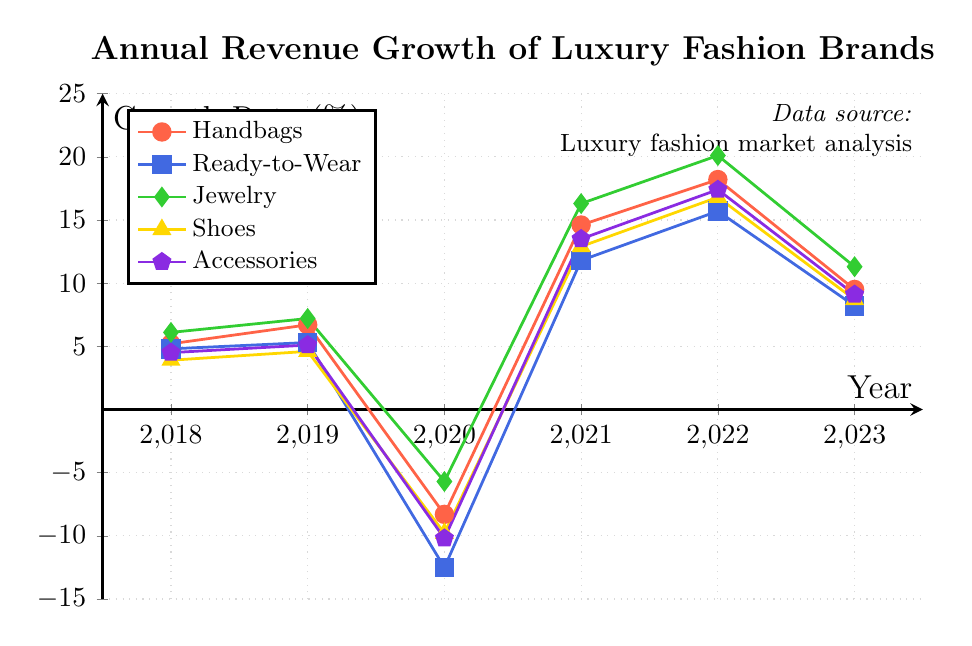What is the growth rate of Jewelry in 2022? To find the growth rate of Jewelry in 2022, look at the value corresponding to Jewelry for the year 2022 on the chart.
Answer: 20.1% How did the revenue growth rate for Ready-to-Wear change from 2020 to 2021? Look at the values for Ready-to-Wear in 2020 and 2021 and subtract the 2020 value from the 2021 value. The growth rate in 2020 was -12.5%, and in 2021 it was 11.8%. So, the change is 11.8 - (-12.5) = 24.3%.
Answer: 24.3% Which category had the highest revenue growth rate in 2019? Compare the growth rates of all categories for the year 2019. The values are 6.7% for Handbags, 5.3% for Ready-to-Wear, 7.2% for Jewelry, 4.6% for Shoes, and 5.1% for Accessories. Jewelry has the highest growth rate.
Answer: Jewelry Between which two consecutive years did Handbags experience the greatest increase in growth rate? Check the growth rates of Handbags for each pair of consecutive years: 
From 2018 to 2019: 6.7 - 5.2 = 1.5 
From 2019 to 2020: -8.3 - 6.7 = -15 (decrease)
From 2020 to 2021: 14.6 - (-8.3) = 22.9 
From 2021 to 2022: 18.2 - 14.6 = 3.6 
From 2022 to 2023: 9.5 - 18.2 = -8.7 (decrease)
The greatest increase is from 2020 to 2021.
Answer: 2020 to 2021 Which category shows the highest variability in growth rate over the years? To find the highest variability, look at the range (difference between the maximum and minimum values) for each category:
Handbags: 18.2 - (-8.3) = 26.5
Ready-to-Wear: 15.7 - (-12.5) = 28.2
Jewelry: 20.1 - (-5.7) = 25.8
Shoes: 16.8 - (-9.8) = 26.6
Accessories: 17.4 - (-10.2) = 27.6
Ready-to-Wear shows the highest variability.
Answer: Ready-to-Wear What is the average growth rate for Accessories from 2018 to 2023? The growth rates for Accessories are 4.5, 5.1, -10.2, 13.5, 17.4, and 9.1. Sum these values and divide by the number of years: (4.5 + 5.1 - 10.2 + 13.5 + 17.4 + 9.1) / 6 = 6.23.
Answer: 6.23 Among all the categories, which one had the lowest growth rate in 2023? Compare the growth rates for all categories in 2023: Handbags (9.5), Ready-to-Wear (8.2), Jewelry (11.3), Shoes (8.7), and Accessories (9.1). Ready-to-Wear had the lowest growth rate.
Answer: Ready-to-Wear How does the growth rate of Shoes in 2020 compare to the growth rate of Accessories in the same year? Look at the values for Shoes and Accessories in 2020: Shoes (-9.8%) and Accessories (-10.2%). Shoes had a better (less negative) growth rate than Accessories in 2020.
Answer: Shoes had a better growth rate If you average the growth rate of Handbags and Shoes in 2022, what do you get? Add the growth rates of Handbags (18.2) and Shoes (16.8) in 2022 and then divide by 2: (18.2 + 16.8) / 2 = 17.5.
Answer: 17.5 How much did the growth rate of Jewelry change from 2022 to 2023? The growth rate for Jewelry in 2022 was 20.1%, and in 2023 it was 11.3%. The change is 20.1 - 11.3 = 8.8%.
Answer: 8.8% 